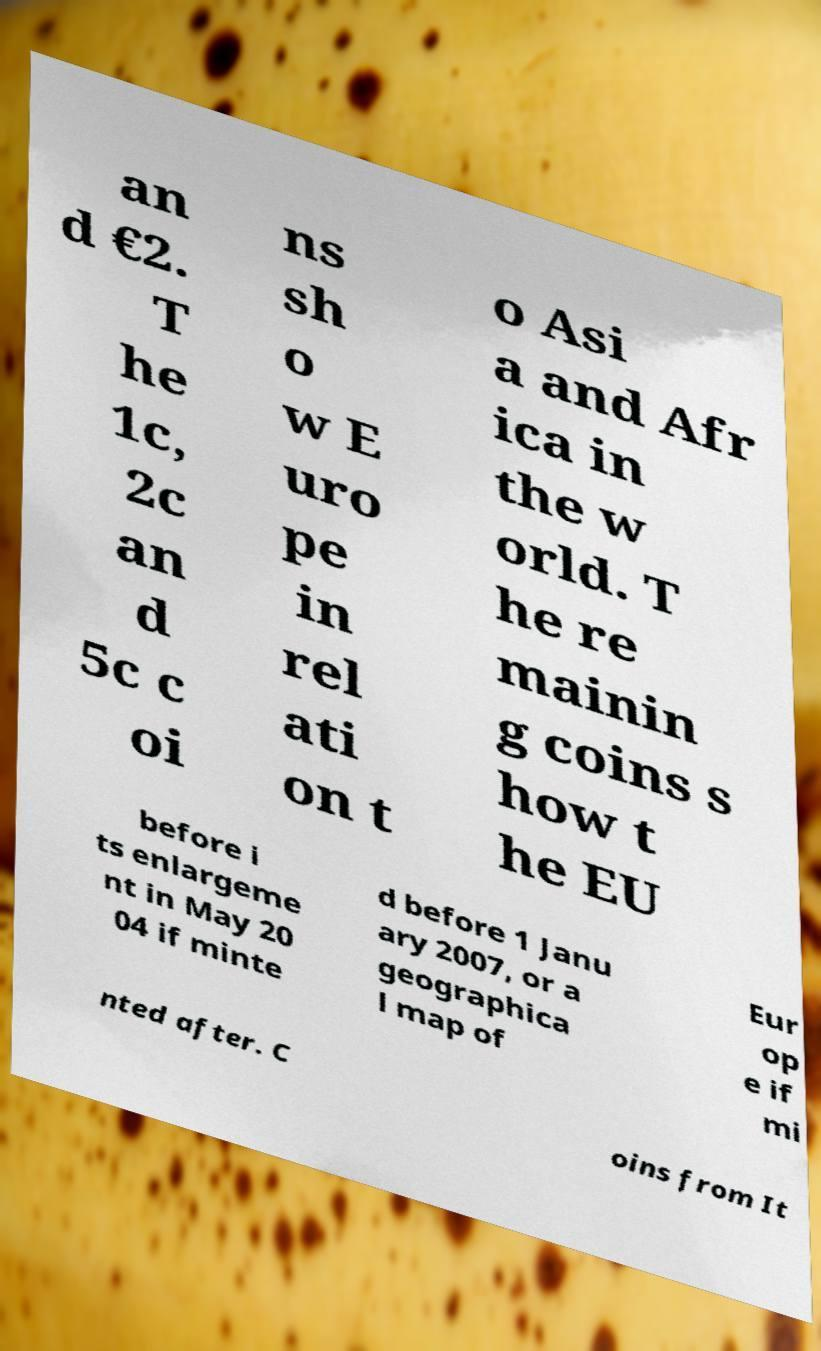Can you accurately transcribe the text from the provided image for me? an d €2. T he 1c, 2c an d 5c c oi ns sh o w E uro pe in rel ati on t o Asi a and Afr ica in the w orld. T he re mainin g coins s how t he EU before i ts enlargeme nt in May 20 04 if minte d before 1 Janu ary 2007, or a geographica l map of Eur op e if mi nted after. C oins from It 